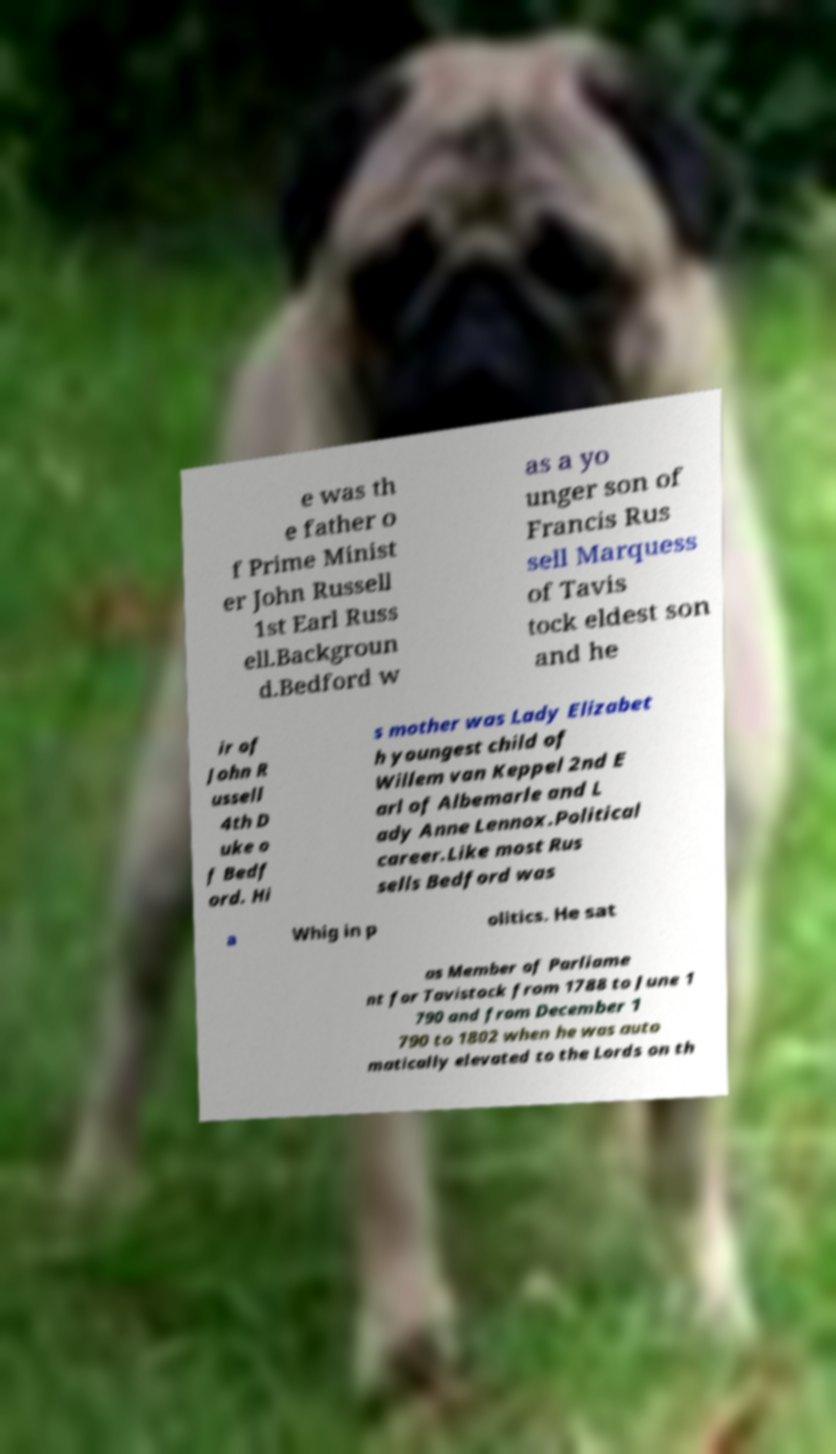I need the written content from this picture converted into text. Can you do that? e was th e father o f Prime Minist er John Russell 1st Earl Russ ell.Backgroun d.Bedford w as a yo unger son of Francis Rus sell Marquess of Tavis tock eldest son and he ir of John R ussell 4th D uke o f Bedf ord. Hi s mother was Lady Elizabet h youngest child of Willem van Keppel 2nd E arl of Albemarle and L ady Anne Lennox.Political career.Like most Rus sells Bedford was a Whig in p olitics. He sat as Member of Parliame nt for Tavistock from 1788 to June 1 790 and from December 1 790 to 1802 when he was auto matically elevated to the Lords on th 